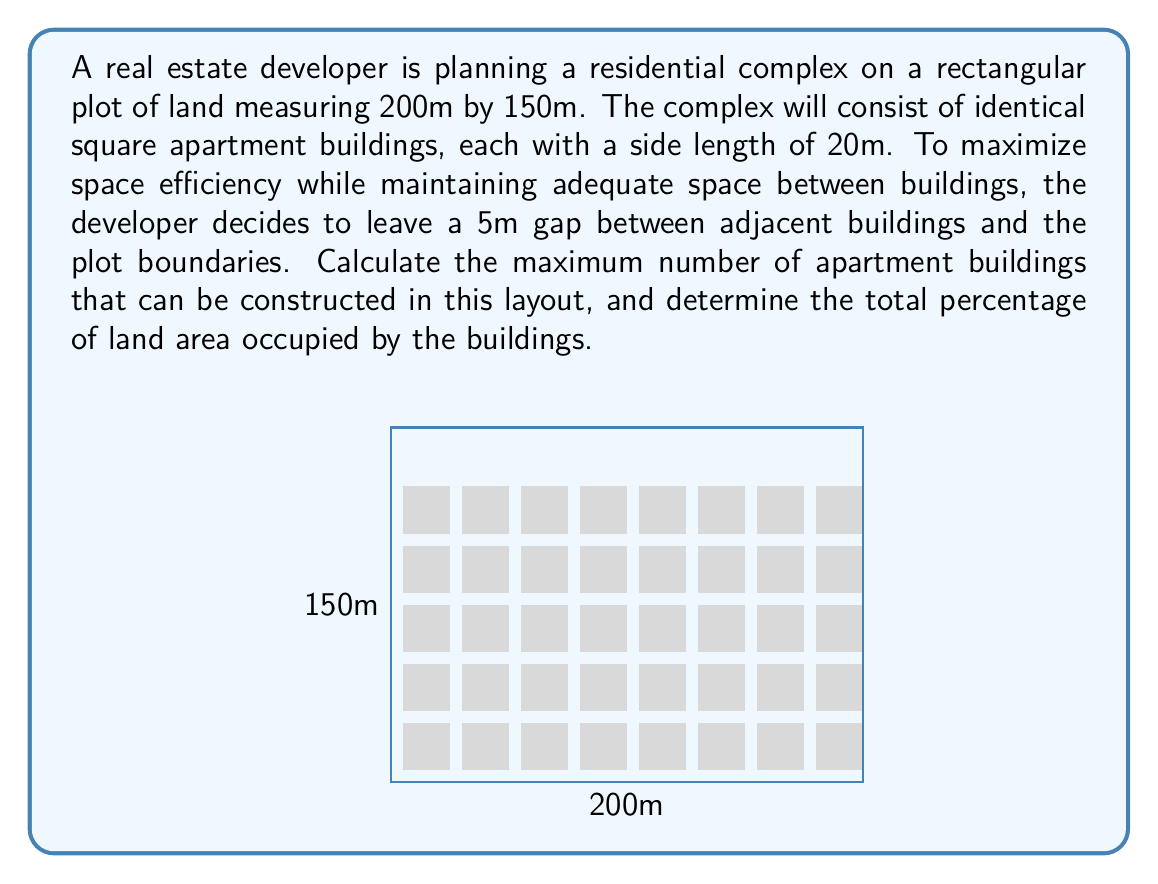Give your solution to this math problem. Let's approach this problem step-by-step:

1) First, let's calculate the number of buildings that can fit along each dimension:

   - Along the 200m side:
     Available space = 200m - (2 * 5m) = 190m
     Number of buildings = 190m ÷ (20m + 5m) = 190 ÷ 25 = 7.6
     We can fit 7 buildings along this side

   - Along the 150m side:
     Available space = 150m - (2 * 5m) = 140m
     Number of buildings = 140m ÷ (20m + 5m) = 140 ÷ 25 = 5.6
     We can fit 5 buildings along this side

2) The total number of buildings is therefore:
   $$7 * 5 = 35$$ buildings

3) To calculate the percentage of land occupied by the buildings:

   - Total land area: $$200m * 150m = 30,000m^2$$
   - Area of one building: $$20m * 20m = 400m^2$$
   - Total area occupied by buildings: $$35 * 400m^2 = 14,000m^2$$

4) Percentage of land occupied:
   $$\frac{14,000m^2}{30,000m^2} * 100\% = 46.67\%$$

Therefore, the maximum number of buildings is 35, and they occupy 46.67% of the total land area.
Answer: 35 buildings; 46.67% land occupation 